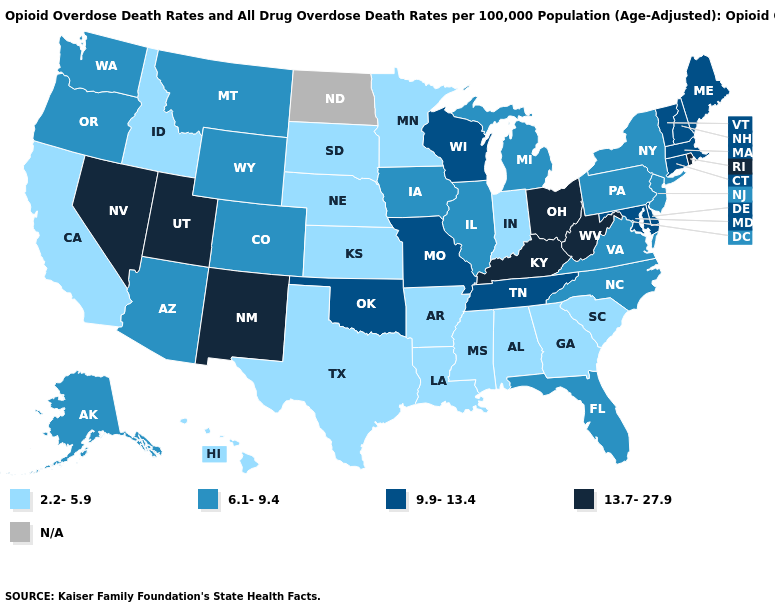What is the highest value in states that border Arkansas?
Short answer required. 9.9-13.4. Among the states that border Massachusetts , which have the highest value?
Short answer required. Rhode Island. What is the highest value in states that border Illinois?
Keep it brief. 13.7-27.9. What is the value of Pennsylvania?
Quick response, please. 6.1-9.4. Among the states that border Washington , which have the lowest value?
Be succinct. Idaho. What is the highest value in the Northeast ?
Short answer required. 13.7-27.9. What is the value of Delaware?
Be succinct. 9.9-13.4. What is the value of Louisiana?
Short answer required. 2.2-5.9. How many symbols are there in the legend?
Keep it brief. 5. How many symbols are there in the legend?
Concise answer only. 5. What is the value of Maine?
Give a very brief answer. 9.9-13.4. Among the states that border New York , which have the lowest value?
Short answer required. New Jersey, Pennsylvania. Name the states that have a value in the range N/A?
Answer briefly. North Dakota. What is the value of South Dakota?
Concise answer only. 2.2-5.9. 